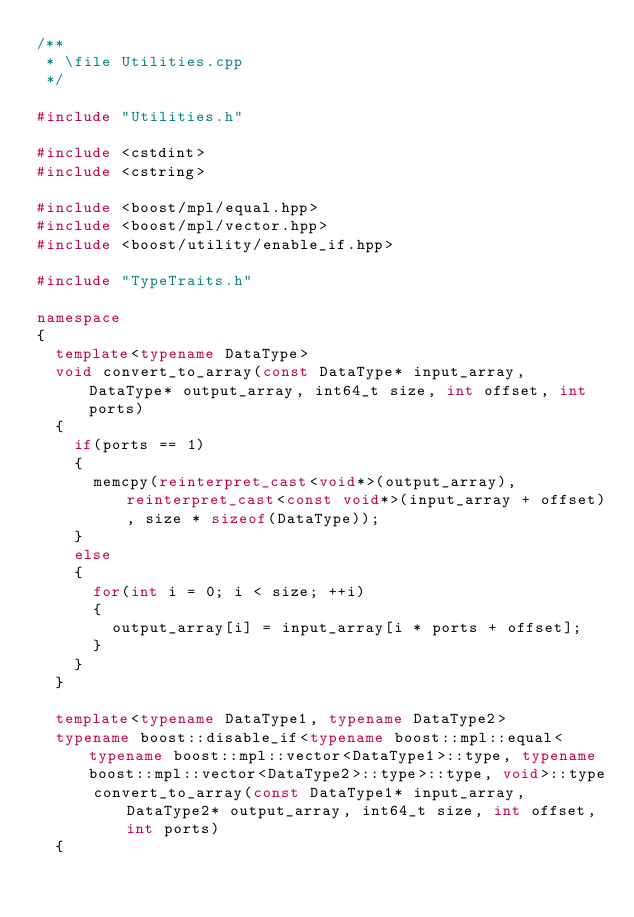Convert code to text. <code><loc_0><loc_0><loc_500><loc_500><_C++_>/**
 * \file Utilities.cpp
 */

#include "Utilities.h"

#include <cstdint>
#include <cstring>

#include <boost/mpl/equal.hpp>
#include <boost/mpl/vector.hpp>
#include <boost/utility/enable_if.hpp>

#include "TypeTraits.h"

namespace
{
  template<typename DataType>
  void convert_to_array(const DataType* input_array, DataType* output_array, int64_t size, int offset, int ports)
  {
    if(ports == 1)
    {
      memcpy(reinterpret_cast<void*>(output_array), reinterpret_cast<const void*>(input_array + offset), size * sizeof(DataType));
    }
    else
    {
      for(int i = 0; i < size; ++i)
      {
        output_array[i] = input_array[i * ports + offset];
      }
    }
  }
  
  template<typename DataType1, typename DataType2>
  typename boost::disable_if<typename boost::mpl::equal<typename boost::mpl::vector<DataType1>::type, typename boost::mpl::vector<DataType2>::type>::type, void>::type
      convert_to_array(const DataType1* input_array, DataType2* output_array, int64_t size, int offset, int ports)
  {</code> 